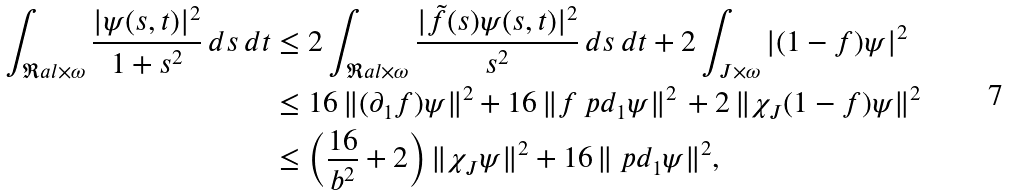Convert formula to latex. <formula><loc_0><loc_0><loc_500><loc_500>\int _ { \Re a l \times \omega } \frac { | \psi ( s , t ) | ^ { 2 } } { 1 + s ^ { 2 } } \, d s \, d t & \leq 2 \int _ { \Re a l \times \omega } \frac { | \tilde { f } ( s ) \psi ( s , t ) | ^ { 2 } } { s ^ { 2 } } \, d s \, d t + 2 \int _ { J \times \omega } | ( 1 - f ) \psi | ^ { 2 } \\ & \leq 1 6 \, \| ( \partial _ { 1 } f ) \psi \| ^ { 2 } + 1 6 \, \| f \ p d _ { 1 } \psi \| ^ { 2 } \, + 2 \, \| \chi _ { J } ( 1 - f ) \psi \| ^ { 2 } \\ & \leq \left ( \frac { 1 6 } { b ^ { 2 } } + 2 \right ) \| \chi _ { J } \psi \| ^ { 2 } + 1 6 \, \| \ p d _ { 1 } \psi \| ^ { 2 } ,</formula> 